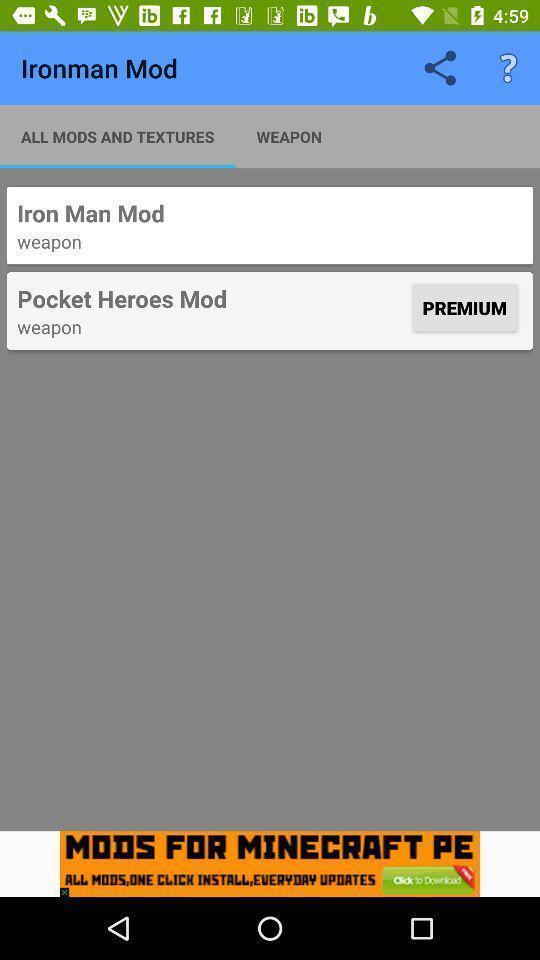Summarize the information in this screenshot. Window displaying list of weapons. 